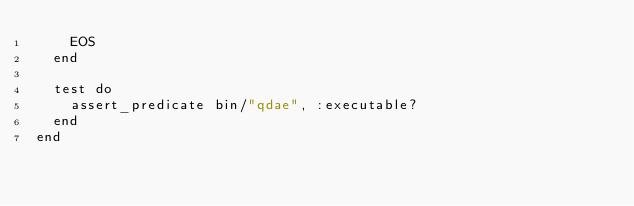<code> <loc_0><loc_0><loc_500><loc_500><_Ruby_>    EOS
  end

  test do
    assert_predicate bin/"qdae", :executable?
  end
end
</code> 